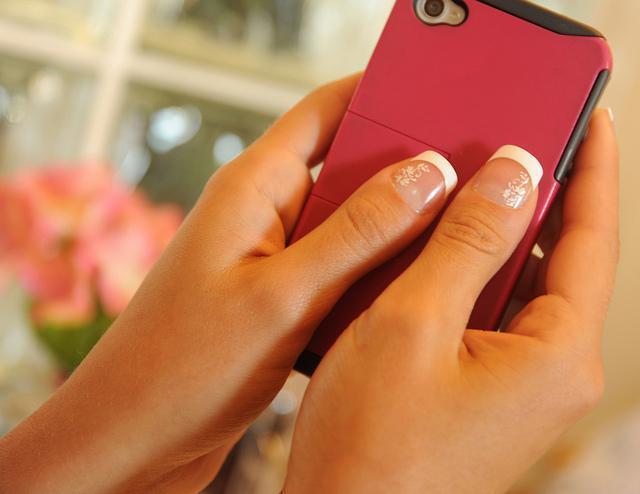How many hands do you see?
Give a very brief answer. 2. How many ski lift chairs are visible?
Give a very brief answer. 0. 